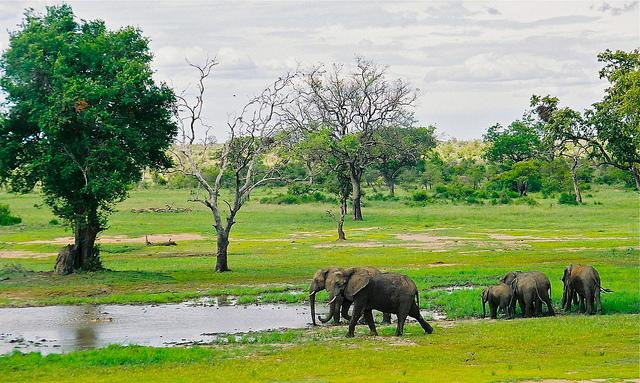What is next to the elephant?

Choices:
A) baby wolf
B) bear
C) trainer
D) water water 